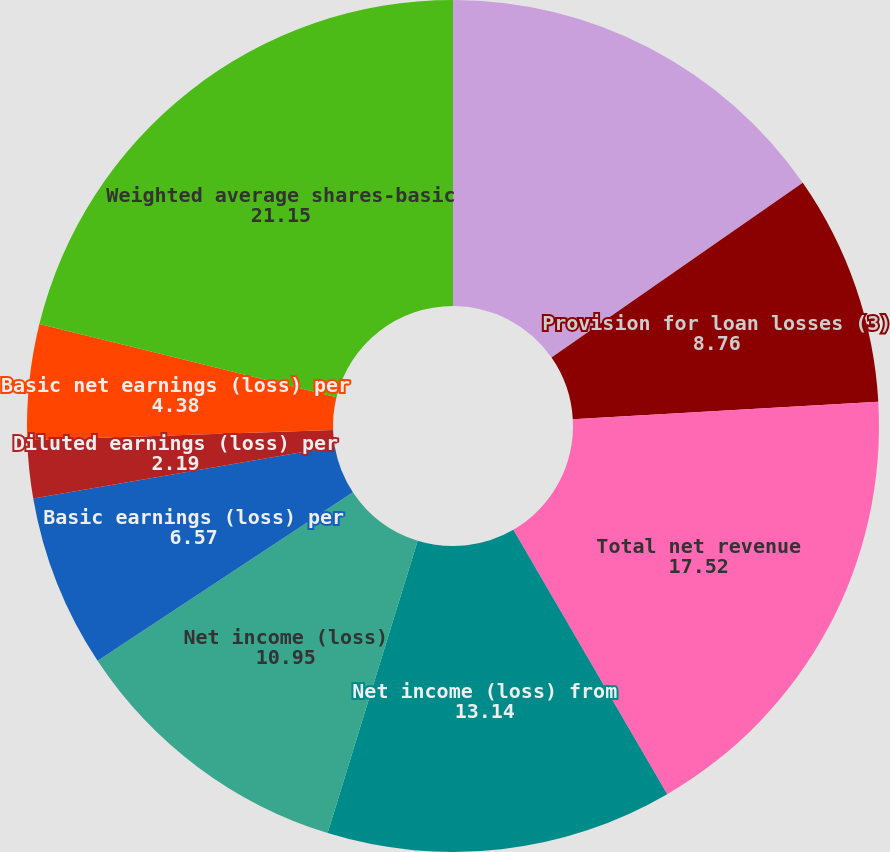Convert chart to OTSL. <chart><loc_0><loc_0><loc_500><loc_500><pie_chart><fcel>Net operating interest income<fcel>Provision for loan losses (3)<fcel>Total net revenue<fcel>Net income (loss) from<fcel>Net income (loss)<fcel>Basic earnings (loss) per<fcel>Diluted earnings (loss) per<fcel>Basic net earnings (loss) per<fcel>Diluted net earnings (loss)<fcel>Weighted average shares-basic<nl><fcel>15.33%<fcel>8.76%<fcel>17.52%<fcel>13.14%<fcel>10.95%<fcel>6.57%<fcel>2.19%<fcel>4.38%<fcel>0.0%<fcel>21.15%<nl></chart> 